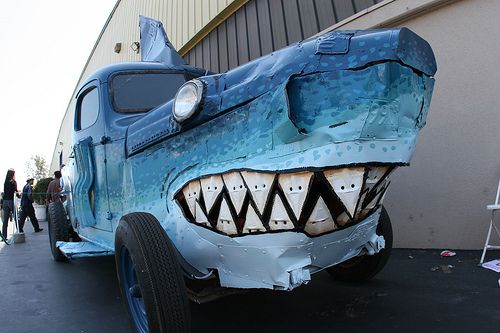<image>
Is the truck behind the shark? Yes. From this viewpoint, the truck is positioned behind the shark, with the shark partially or fully occluding the truck. 